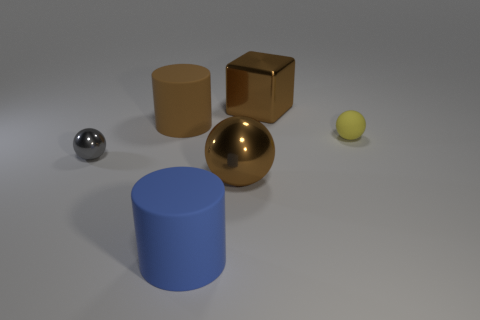What is the material of the cube that is the same color as the big metallic sphere?
Give a very brief answer. Metal. Is the color of the large block the same as the big ball?
Your answer should be very brief. Yes. There is a brown cylinder that is the same size as the brown shiny block; what is its material?
Offer a very short reply. Rubber. What number of metal things are in front of the tiny rubber object?
Provide a short and direct response. 2. Does the cylinder in front of the tiny yellow sphere have the same material as the cylinder left of the blue cylinder?
Your response must be concise. Yes. There is a large shiny object that is in front of the shiny object that is behind the tiny ball that is to the right of the big brown block; what is its shape?
Make the answer very short. Sphere. There is a tiny matte thing; what shape is it?
Your answer should be very brief. Sphere. There is a brown rubber object that is the same size as the brown metal block; what is its shape?
Your answer should be very brief. Cylinder. What number of other things are the same color as the large metallic ball?
Keep it short and to the point. 2. There is a matte thing right of the large blue rubber thing; does it have the same shape as the small thing that is to the left of the large blue matte object?
Keep it short and to the point. Yes. 